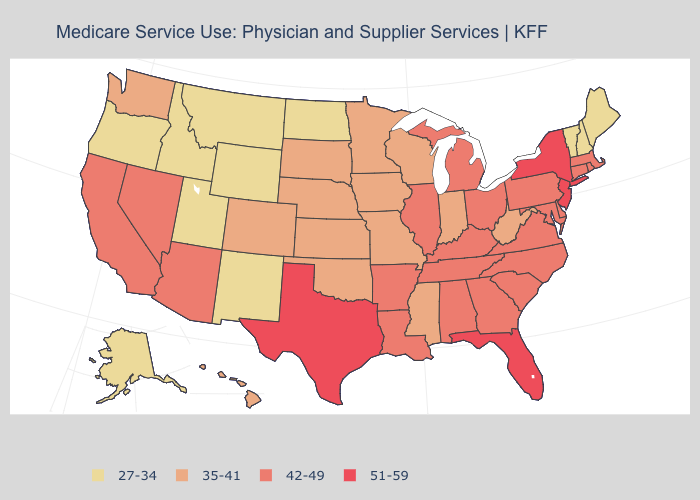Does New York have the highest value in the USA?
Write a very short answer. Yes. How many symbols are there in the legend?
Concise answer only. 4. What is the highest value in the West ?
Give a very brief answer. 42-49. Does North Dakota have the lowest value in the MidWest?
Write a very short answer. Yes. Does Ohio have a higher value than Colorado?
Quick response, please. Yes. Does Maine have the lowest value in the USA?
Answer briefly. Yes. Is the legend a continuous bar?
Be succinct. No. What is the highest value in states that border Arizona?
Keep it brief. 42-49. Name the states that have a value in the range 51-59?
Write a very short answer. Florida, New Jersey, New York, Texas. Does Pennsylvania have the lowest value in the Northeast?
Quick response, please. No. What is the value of Nebraska?
Answer briefly. 35-41. Name the states that have a value in the range 35-41?
Quick response, please. Colorado, Hawaii, Indiana, Iowa, Kansas, Minnesota, Mississippi, Missouri, Nebraska, Oklahoma, South Dakota, Washington, West Virginia, Wisconsin. Among the states that border New Hampshire , which have the lowest value?
Answer briefly. Maine, Vermont. Name the states that have a value in the range 27-34?
Keep it brief. Alaska, Idaho, Maine, Montana, New Hampshire, New Mexico, North Dakota, Oregon, Utah, Vermont, Wyoming. 